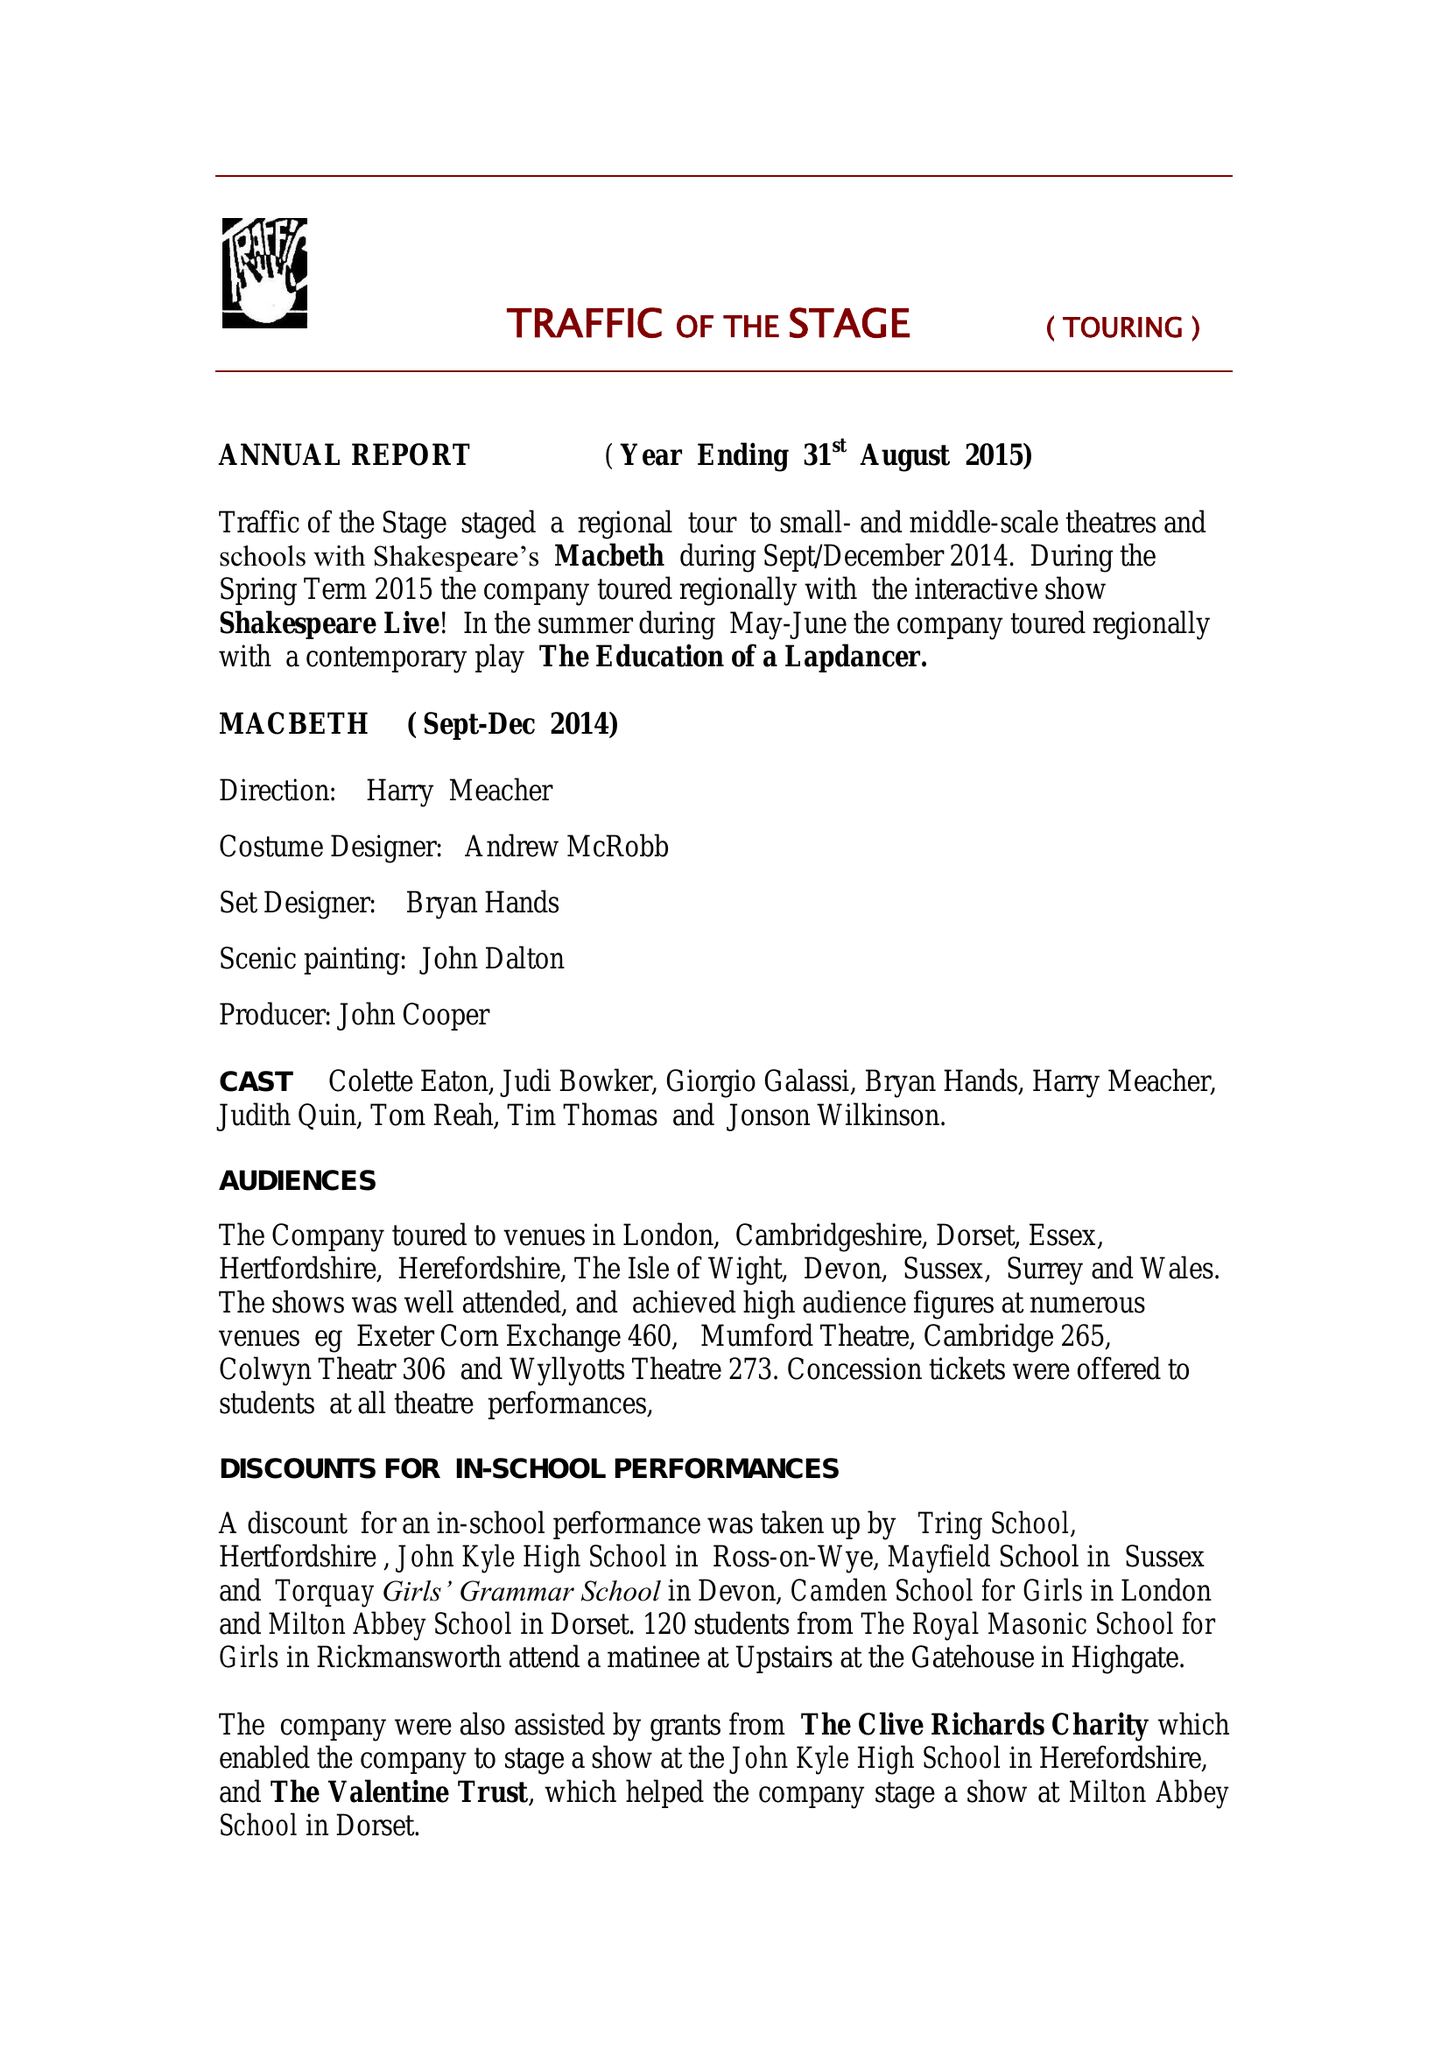What is the value for the income_annually_in_british_pounds?
Answer the question using a single word or phrase. 47881.62 